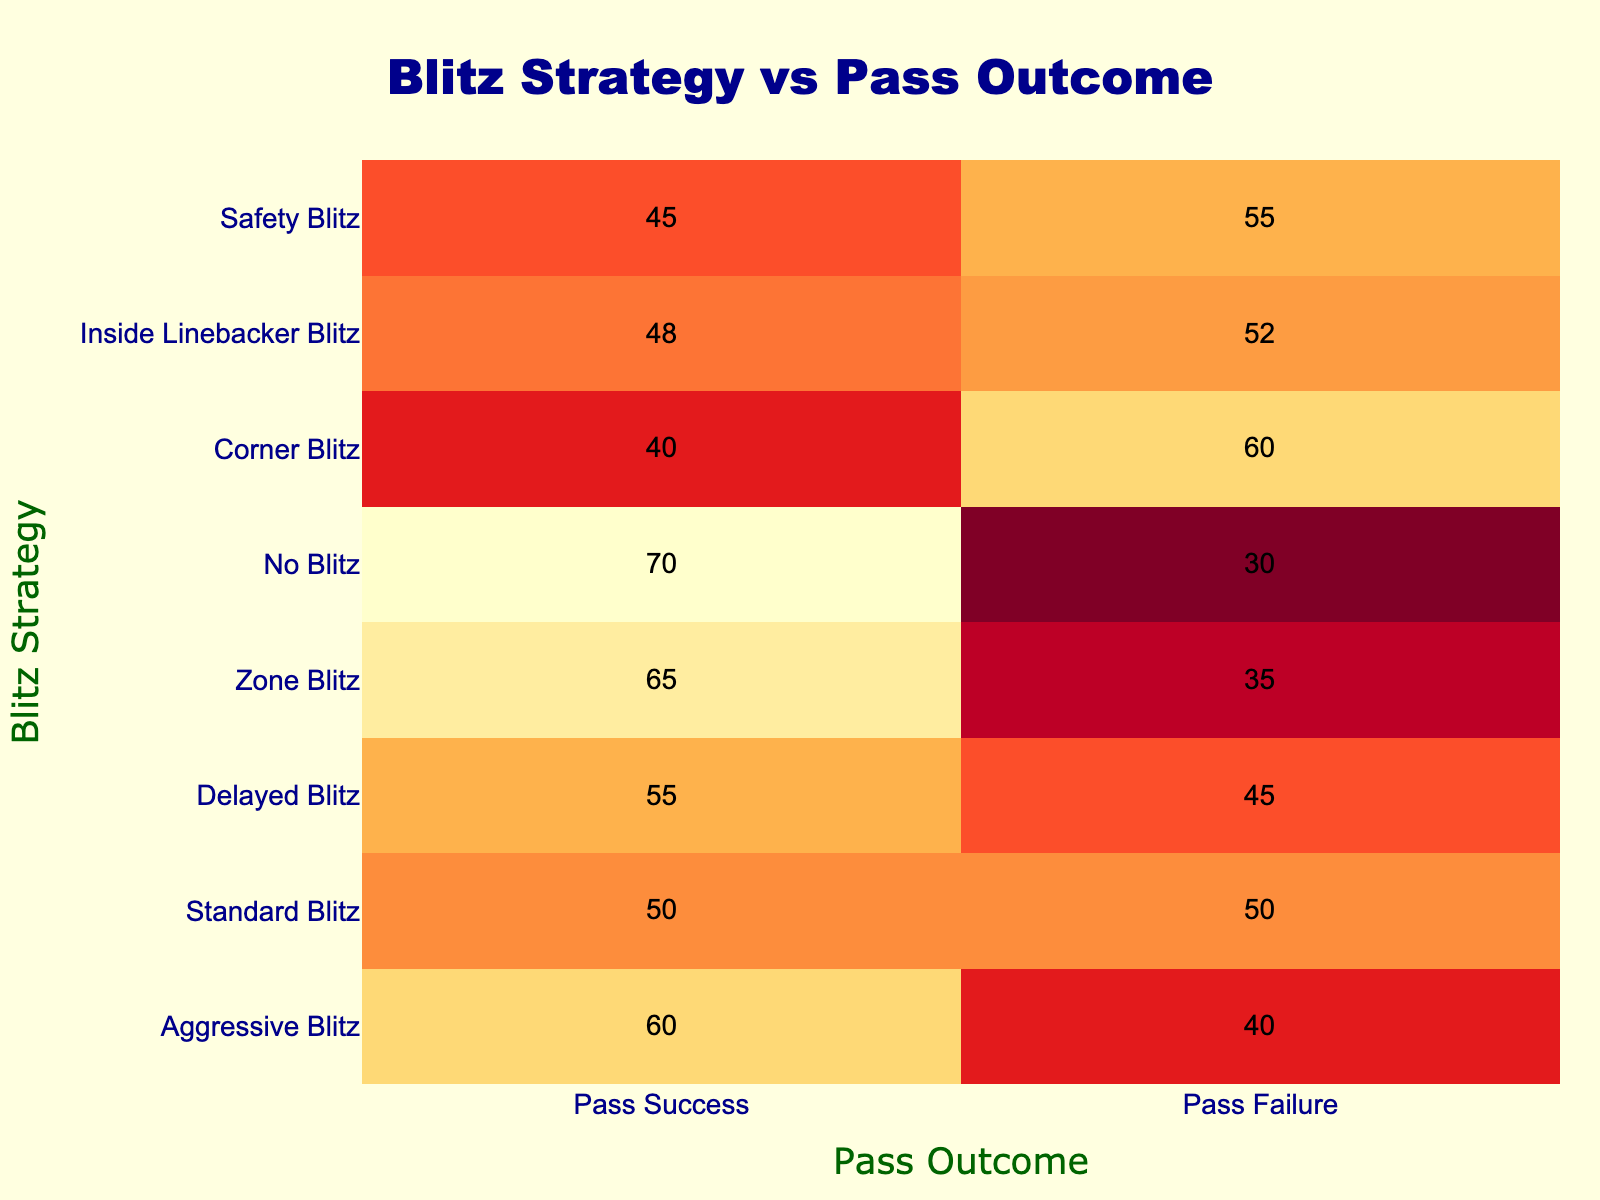What is the pass success rate for the Aggressive Blitz strategy? The table shows that for the Aggressive Blitz strategy, the Pass Success number is 60. Therefore, the pass success rate is 60.
Answer: 60 What is the pass failure rate when using a Zone Blitz? According to the table, the Zone Blitz has a Pass Failure number of 35. Hence, the pass failure rate is 35.
Answer: 35 Which blitz strategy has the highest pass success rate? By examining the Pass Success column, Zone Blitz has the highest value at 65. So, the blitz strategy with the highest pass success rate is Zone Blitz.
Answer: Zone Blitz What is the average pass success rate across all blitz strategies? To find the average, we sum the Pass Success values (60 + 50 + 55 + 65 + 70 + 40 + 48 + 45) = 433. Since there are 8 strategies, the average is 433 / 8 = 54.125.
Answer: 54.125 Is it true that the No Blitz strategy has a higher success rate than the Corner Blitz strategy? The pass success rate for No Blitz is 70, while for Corner Blitz it is 40. Since 70 is greater than 40, the answer is yes.
Answer: Yes What is the difference in pass success rates between the Delayed Blitz and the Inside Linebacker Blitz? The Pass Success for Delayed Blitz is 55, and for Inside Linebacker Blitz, it is 48. The difference is 55 - 48 = 7.
Answer: 7 Which two blitz strategies have the closest pass failure rates? A comparison of the Pass Failure column shows that Standard Blitz (50) and Inside Linebacker Blitz (52) have pass failure rates that are closest. The difference is only 2.
Answer: Standard Blitz and Inside Linebacker Blitz If we were to combine the success rates of the Delayed Blitz and Safety Blitz, what would the total be? The Pass Success for Delayed Blitz is 55, and for Safety Blitz, it is 45. Adding these gives us 55 + 45 = 100.
Answer: 100 How many blitz strategies have a pass failure rate of 50 or below? In the Pass Failure column, the strategies with a rate of 50 or below are Aggressive Blitz (40), Zone Blitz (35), and Corner Blitz (60 but above 50). Thus, only Aggressive Blitz and Zone Blitz count, resulting in a total of 2.
Answer: 2 